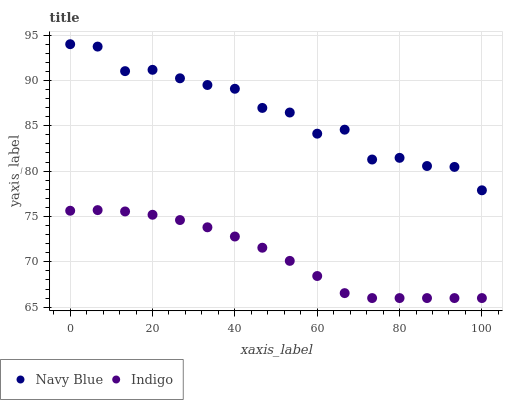Does Indigo have the minimum area under the curve?
Answer yes or no. Yes. Does Navy Blue have the maximum area under the curve?
Answer yes or no. Yes. Does Indigo have the maximum area under the curve?
Answer yes or no. No. Is Indigo the smoothest?
Answer yes or no. Yes. Is Navy Blue the roughest?
Answer yes or no. Yes. Is Indigo the roughest?
Answer yes or no. No. Does Indigo have the lowest value?
Answer yes or no. Yes. Does Navy Blue have the highest value?
Answer yes or no. Yes. Does Indigo have the highest value?
Answer yes or no. No. Is Indigo less than Navy Blue?
Answer yes or no. Yes. Is Navy Blue greater than Indigo?
Answer yes or no. Yes. Does Indigo intersect Navy Blue?
Answer yes or no. No. 